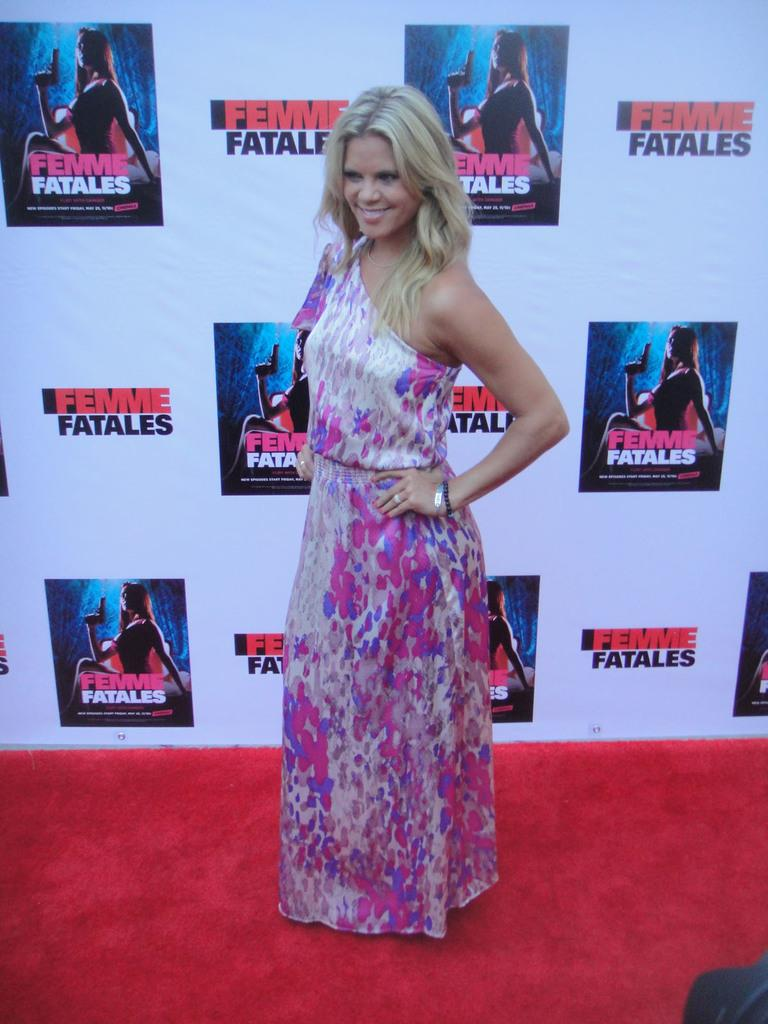What is the person in the image wearing? The person in the image is wearing a dress. Can you describe the colors of the dress? The dress has pink, blue, and cream colors. What can be seen in the background of the image? There is a banner in the background of the image. How many letters are visible on the suit in the image? There is no suit present in the image, and therefore no letters can be seen on it. 